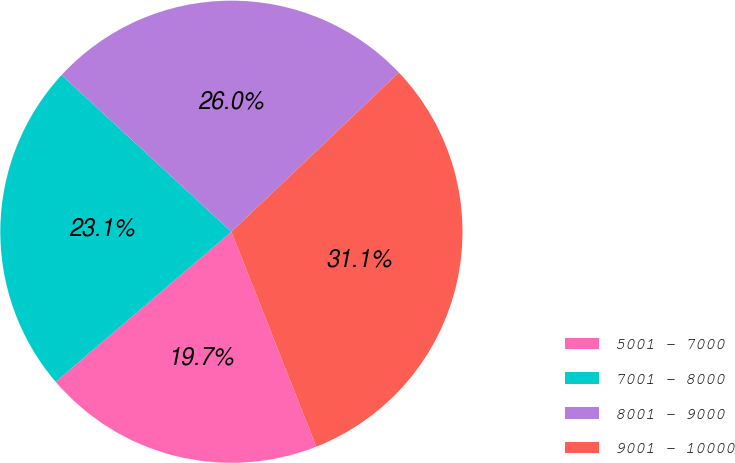Convert chart to OTSL. <chart><loc_0><loc_0><loc_500><loc_500><pie_chart><fcel>5001 - 7000<fcel>7001 - 8000<fcel>8001 - 9000<fcel>9001 - 10000<nl><fcel>19.74%<fcel>23.11%<fcel>26.04%<fcel>31.11%<nl></chart> 